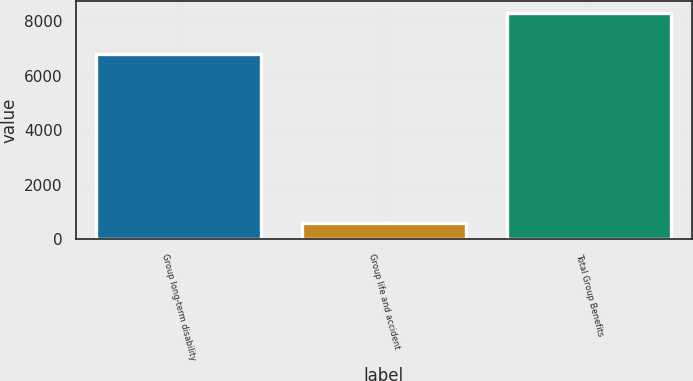Convert chart to OTSL. <chart><loc_0><loc_0><loc_500><loc_500><bar_chart><fcel>Group long-term disability<fcel>Group life and accident<fcel>Total Group Benefits<nl><fcel>6807<fcel>609<fcel>8303<nl></chart> 